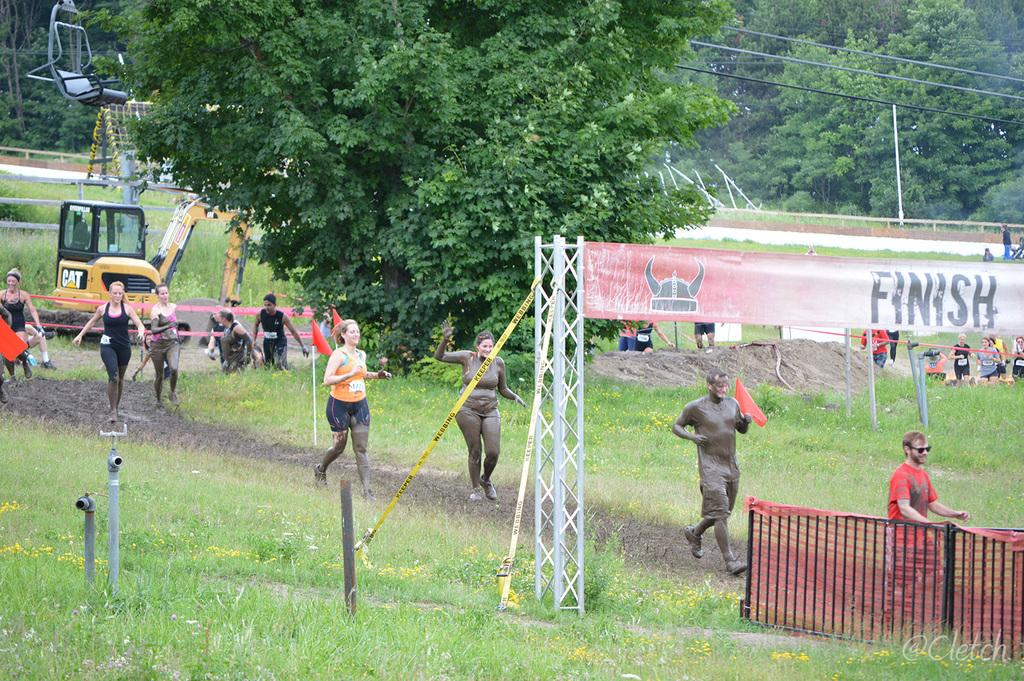Provide a one-sentence caption for the provided image. A group of mud covered runners approaching the finish banner in a field next to a ski lift. 